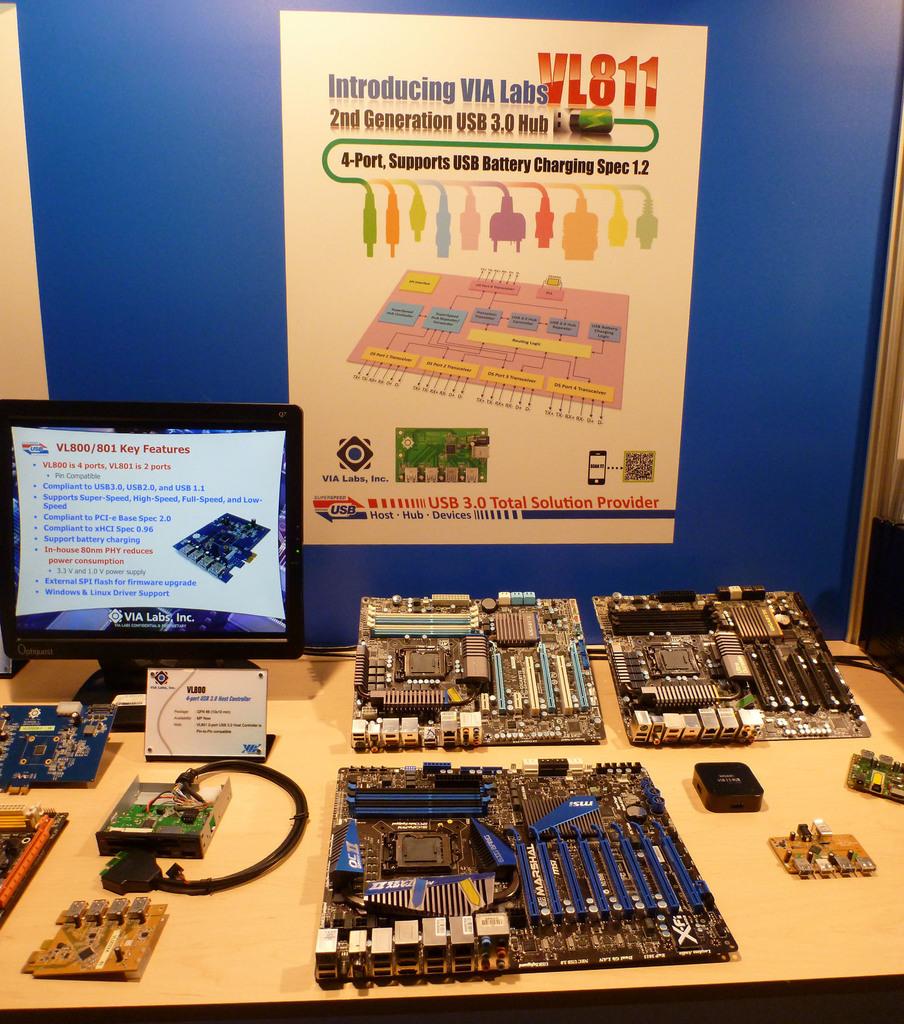What is the lab number on the top right of the poster?
Provide a succinct answer. Vl811. How many ports?
Give a very brief answer. 4. 